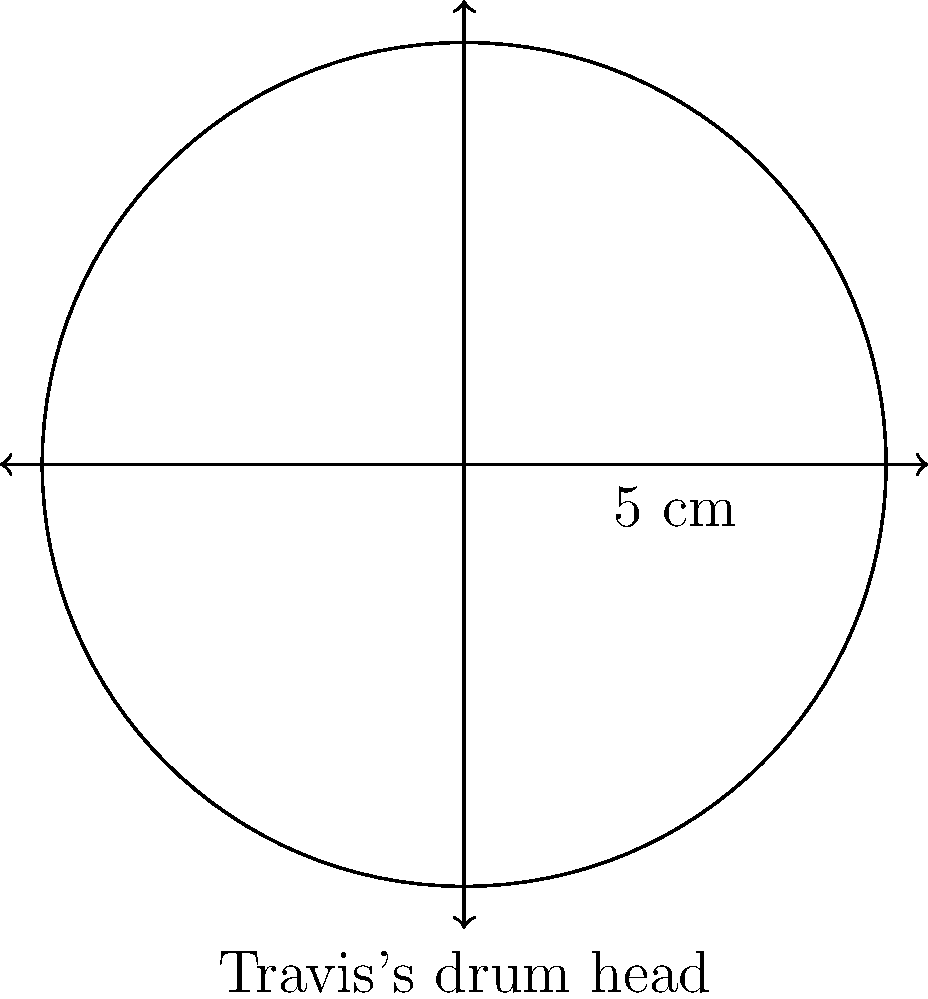Travis Barker's iconic drum set includes a snare drum with a head diameter of 10 cm. If the circumference of this drum head represents the total length of Blink-182's discography in hours, calculate the total playtime of their albums. Use $\pi \approx 3.14$ for your calculations. Let's approach this step-by-step:

1) We're given the diameter of the drum head, which is 10 cm. We need to find the circumference.

2) The formula for the circumference of a circle is:
   $$C = \pi d$$
   where $C$ is the circumference, $\pi$ is pi, and $d$ is the diameter.

3) Substituting our values:
   $$C = 3.14 \times 10 \text{ cm}$$

4) Calculating:
   $$C = 31.4 \text{ cm}$$

5) In this context, each centimeter represents an hour of playtime.

Therefore, the total playtime of Blink-182's discography is 31.4 hours.
Answer: 31.4 hours 